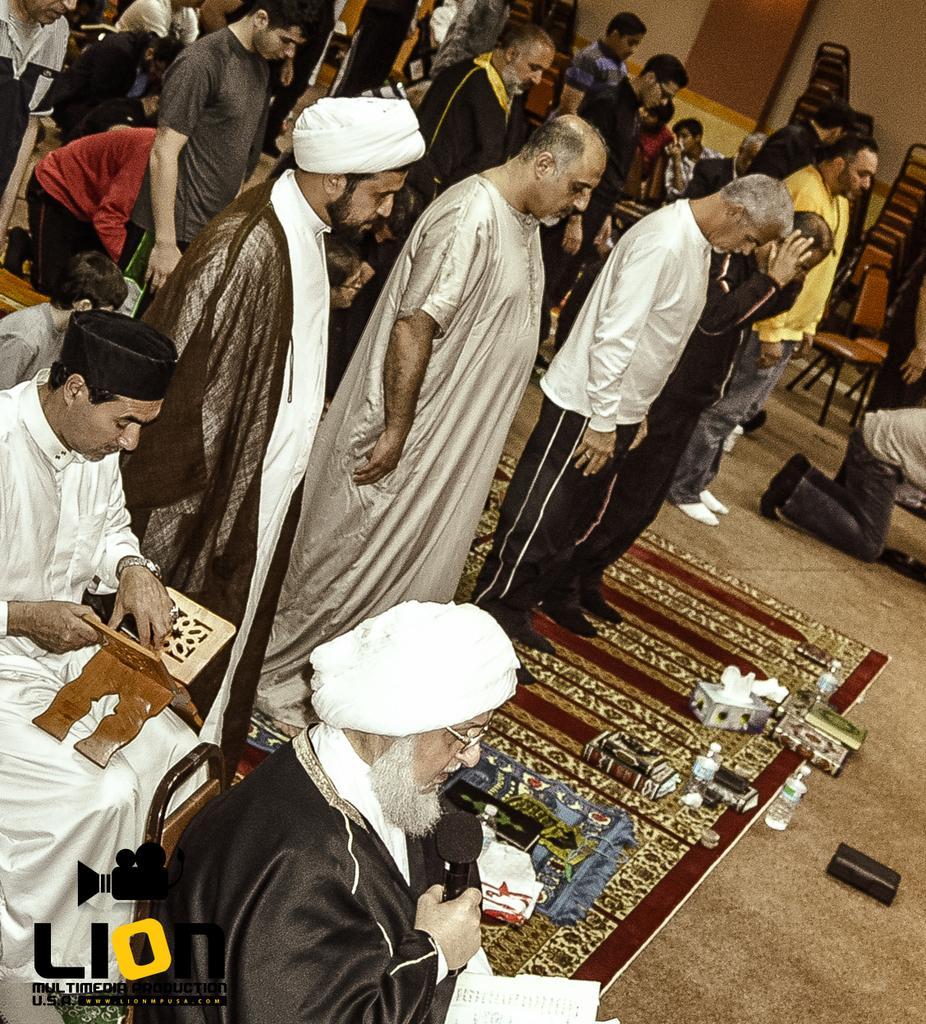How would you summarize this image in a sentence or two? In this image I can see a group of people are standing on the floor and few are holding some objects in their hand. In the background I can see chairs, wall, logo and some objects. This image is taken may be in a hall. 